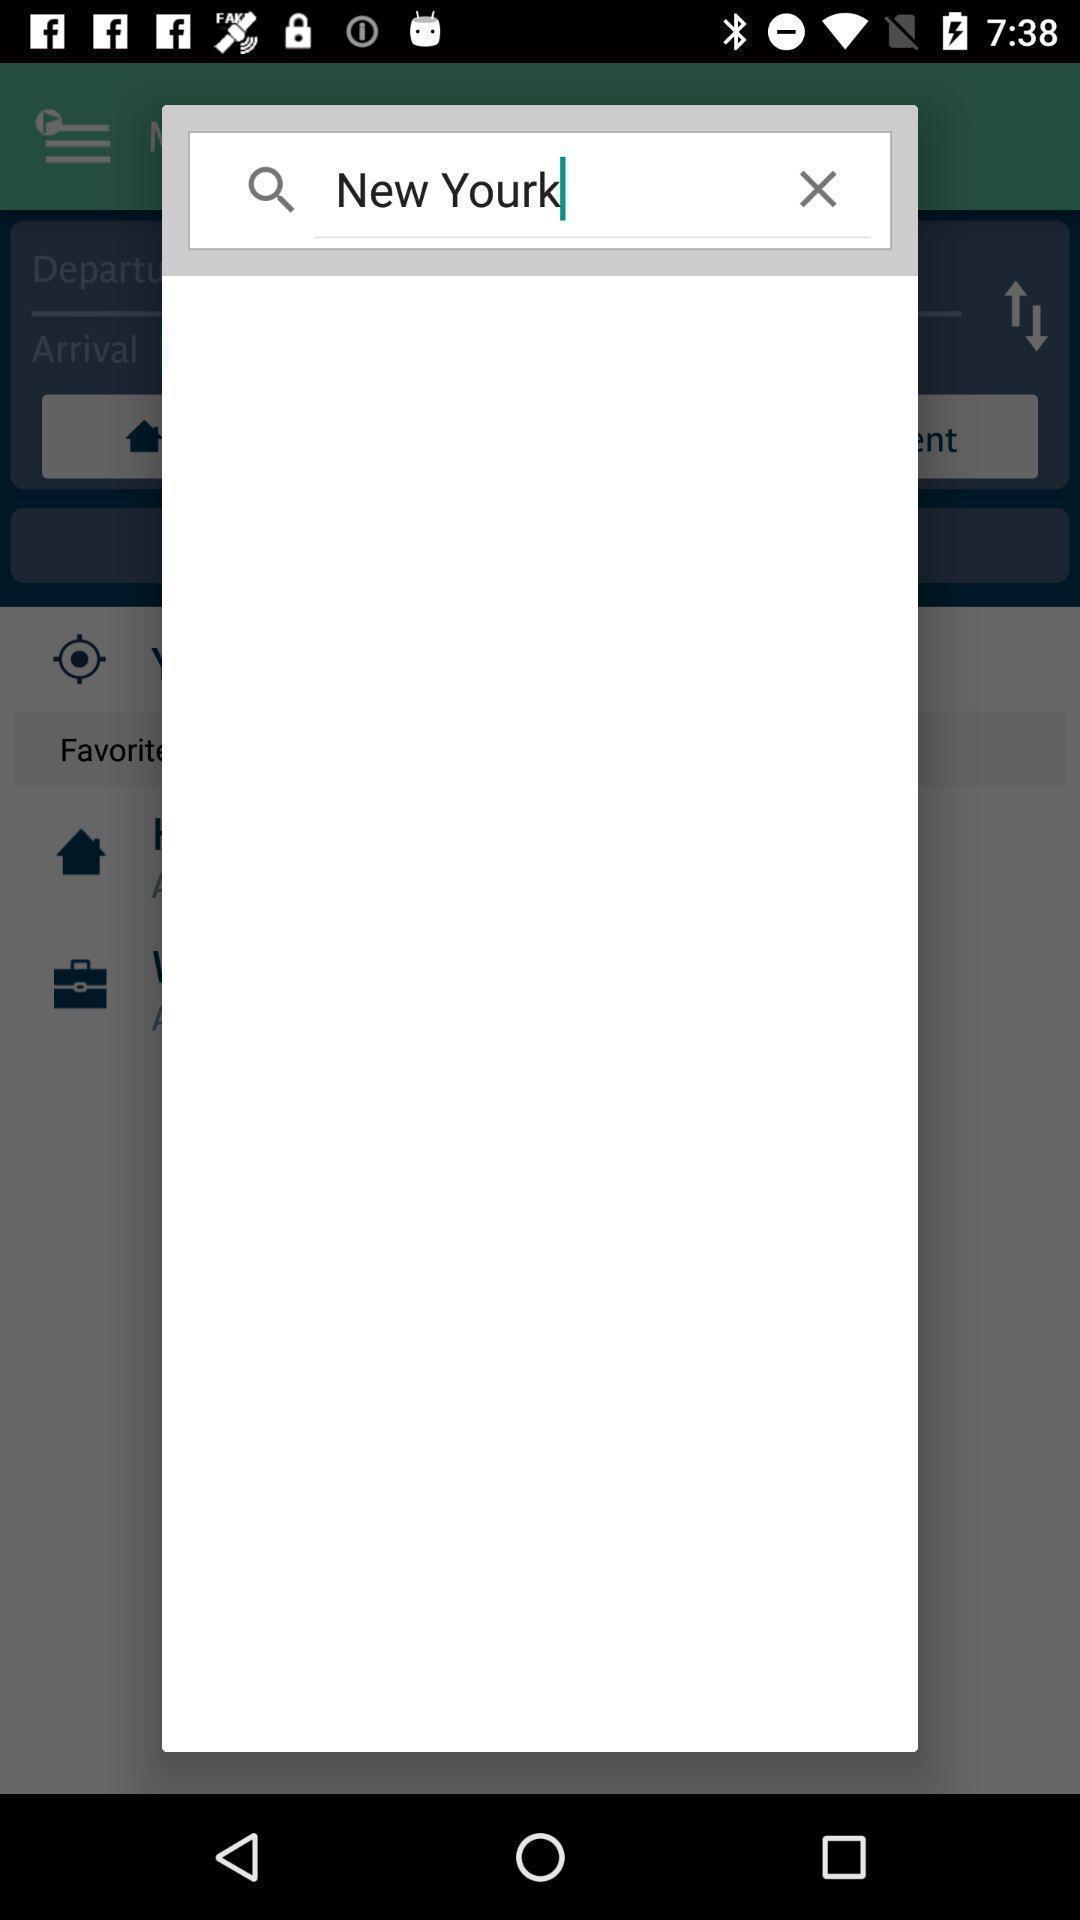What can you discern from this picture? Popup page for searching a place. 